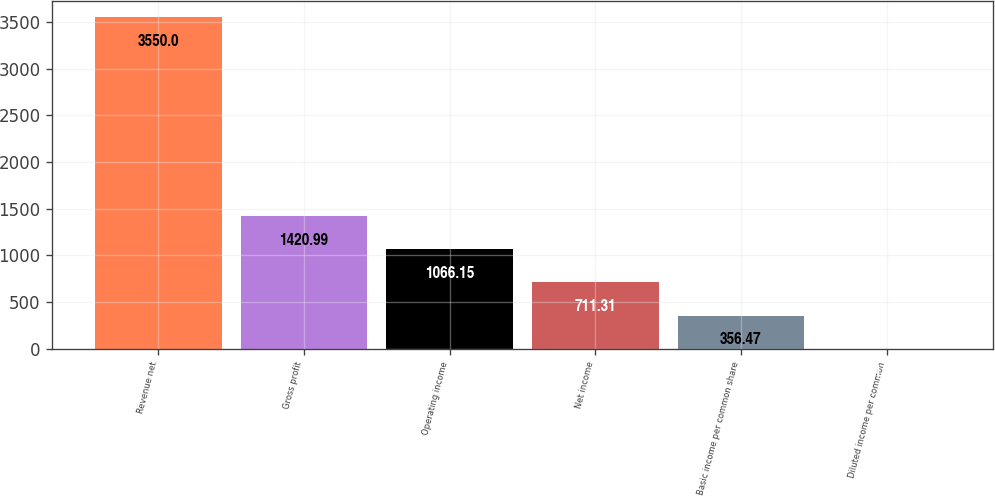Convert chart. <chart><loc_0><loc_0><loc_500><loc_500><bar_chart><fcel>Revenue net<fcel>Gross profit<fcel>Operating income<fcel>Net income<fcel>Basic income per common share<fcel>Diluted income per common<nl><fcel>3550<fcel>1420.99<fcel>1066.15<fcel>711.31<fcel>356.47<fcel>1.63<nl></chart> 